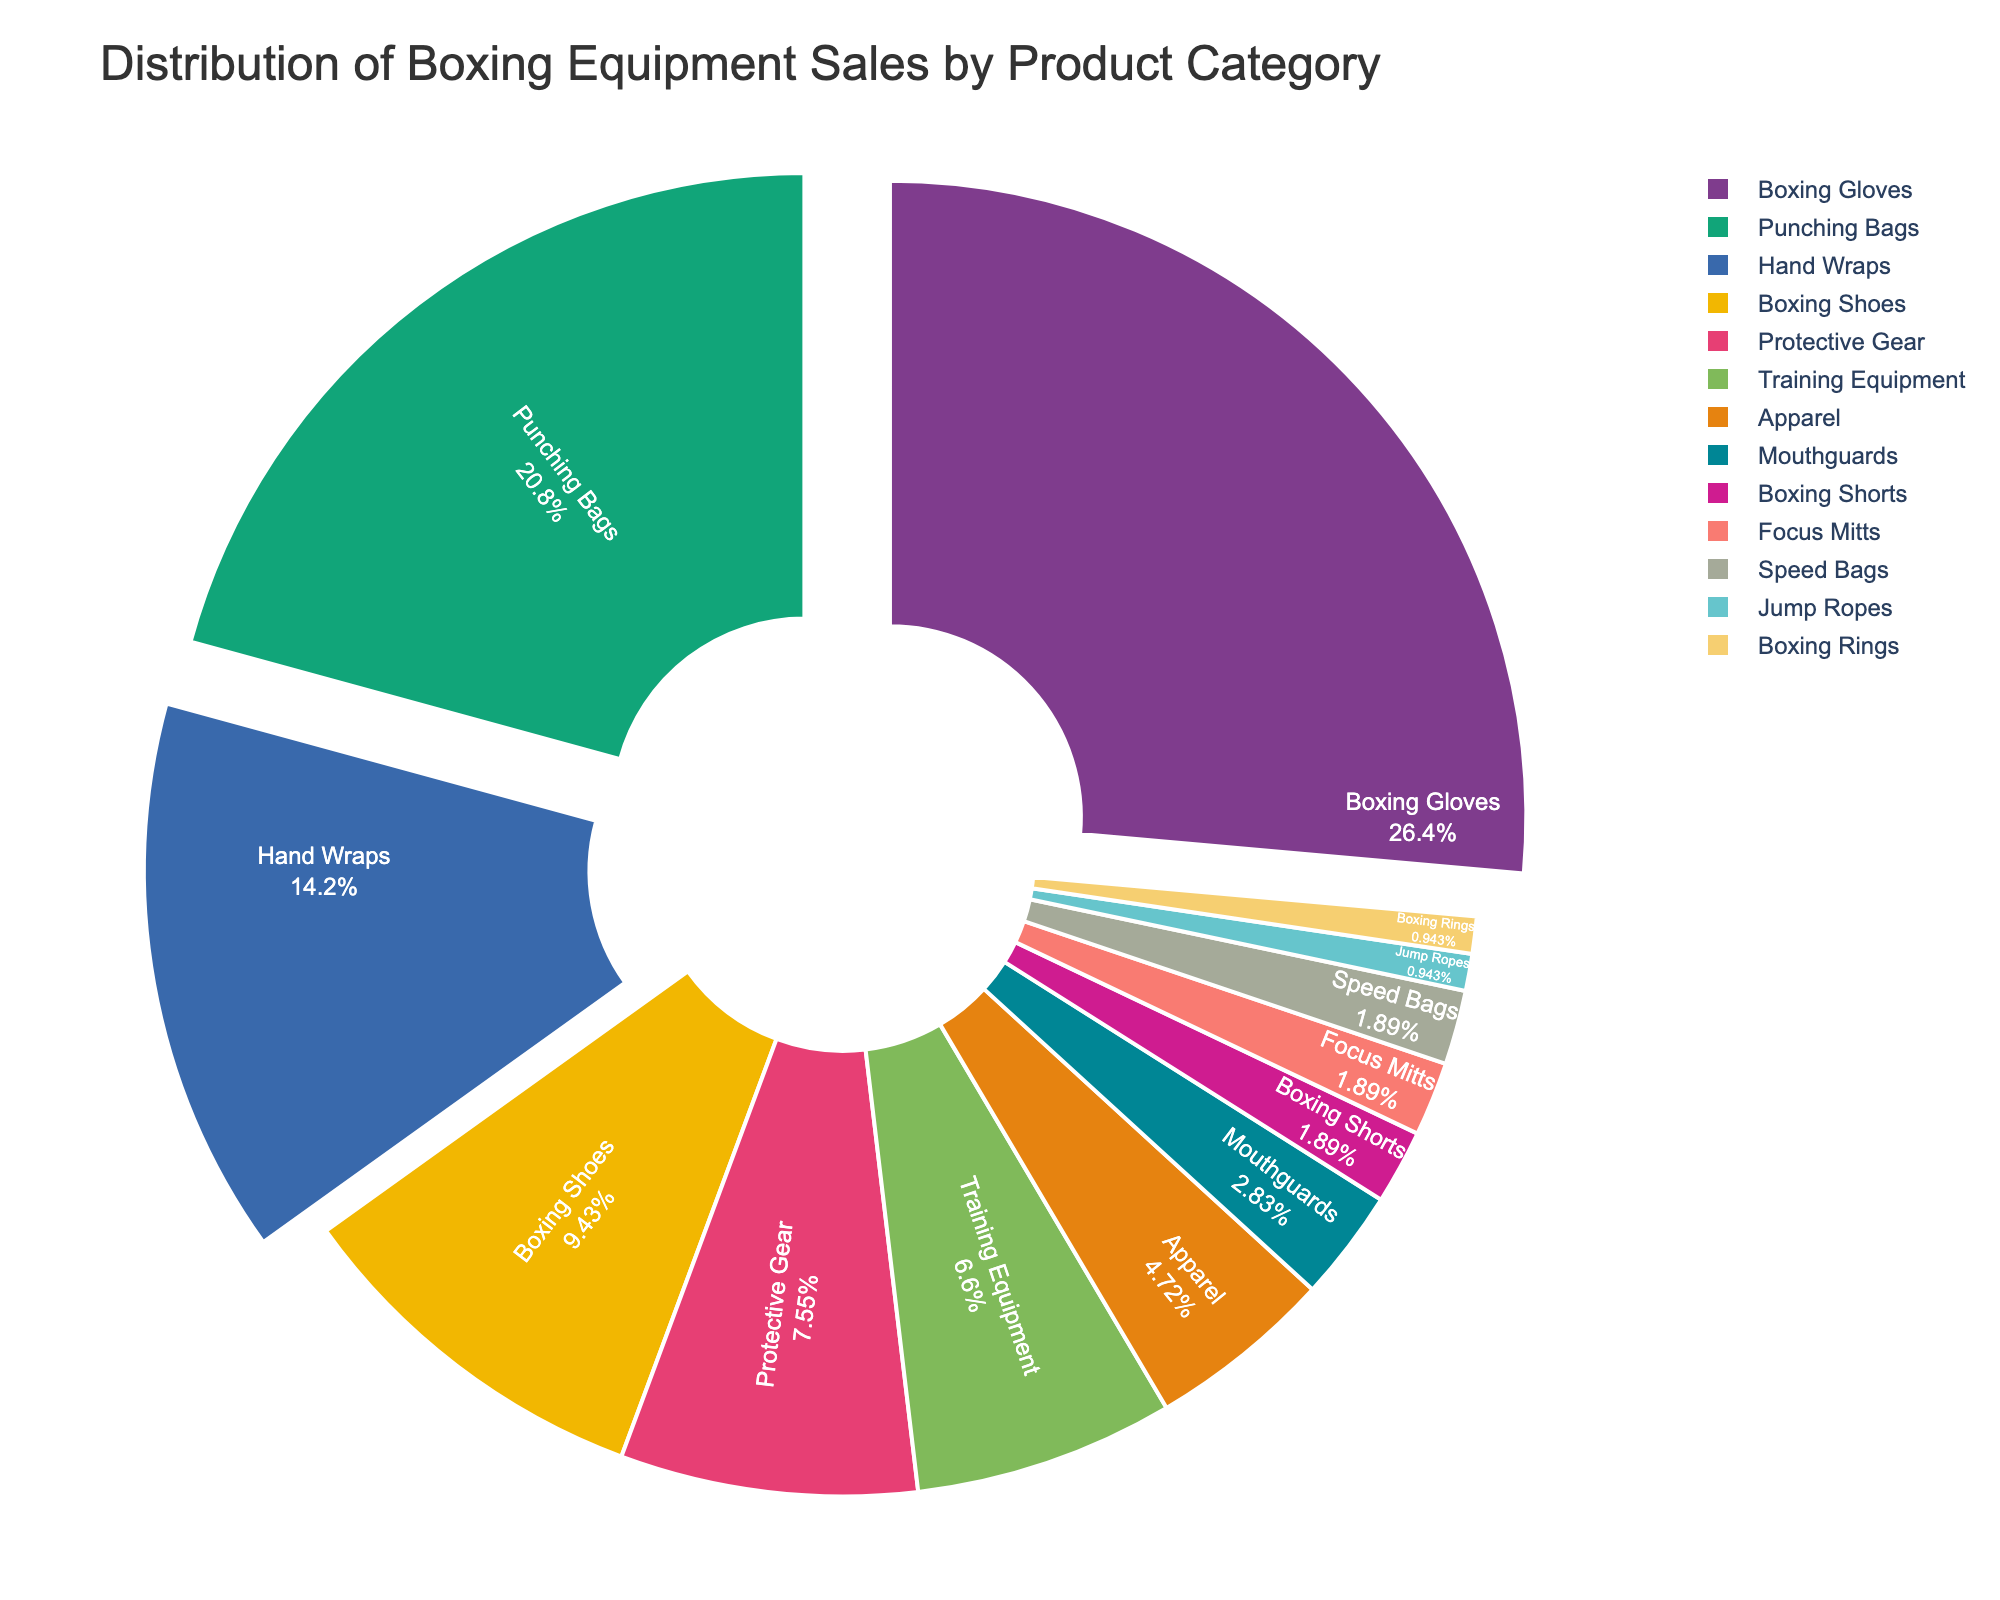Which product category has the largest share of sales? The largest segment in the pie chart represents Boxing Gloves, which accounts for the highest percentage of sales.
Answer: Boxing Gloves What percentage of sales do Boxing Gloves and Punching Bags together represent? Boxing Gloves have 28% of sales and Punching Bags have 22%, summing them together gives 28% + 22% = 50%.
Answer: 50% Which product category has the smallest share of sales? The smallest segments in the pie chart represent Jump Ropes and Boxing Rings, each with 1% of sales.
Answer: Jump Ropes and Boxing Rings Are the sales of Hand Wraps greater than the combined sales of Mouthguards and Boxing Shorts? Hand Wraps account for 15% of sales, while Mouthguards and Boxing Shorts together account for 3% + 2% = 5%, so Hand Wraps have a greater share.
Answer: Yes Is the combined share of Protective Gear, Training Equipment, and Apparel greater than the share of Punching Bags? Protective Gear has 8%, Training Equipment has 7%, and Apparel has 5%; summing them together gives 8% + 7% + 5% = 20%, which is less than Punching Bags' 22%.
Answer: No How much greater is the share of Boxing Shoes compared to Speed Bags? Boxing Shoes account for 10% of sales, and Speed Bags account for 2%, so Boxing Shoes have 10% - 2% = 8% more sales.
Answer: 8% Is the share of sales for Protective Gear larger than that for Training Equipment? Protective Gear has 8% of sales, and Training Equipment has 7%, so Protective Gear has a larger share.
Answer: Yes What portion of the pie chart is covered by categories with less than 5% sales? The categories with less than 5% sales are Mouthguards (3%), Boxing Shorts (2%), Focus Mitts (2%), Speed Bags (2%), Jump Ropes (1%), and Boxing Rings (1%). Summing them gives 3% + 2% + 2% + 2% + 1% + 1% = 11%.
Answer: 11% Which is larger: the share of sales for Hand Wraps or Boxing Shoes and Protective Gear combined? Hand Wraps account for 15%. Boxing Shoes (10%) and Protective Gear (8%) combined is 10% + 8% = 18%, so the combined share is larger.
Answer: Boxing Shoes and Protective Gear combined What is the difference between the highest and lowest product category shares? The highest share is Boxing Gloves at 28%, and the lowest share is Jump Ropes and Boxing Rings at 1% each. The difference is 28% - 1% = 27%.
Answer: 27% 